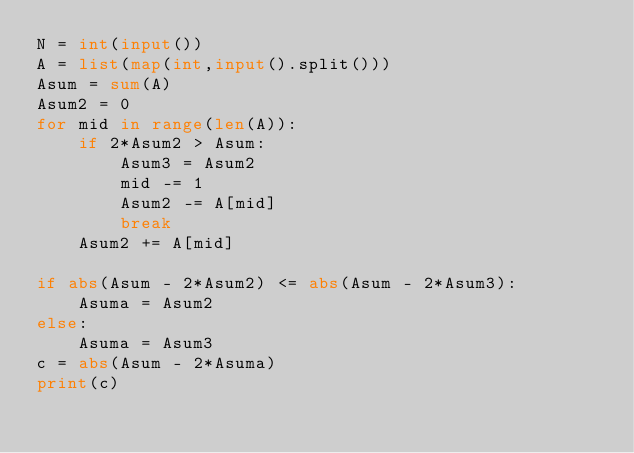<code> <loc_0><loc_0><loc_500><loc_500><_Python_>N = int(input())
A = list(map(int,input().split()))
Asum = sum(A)
Asum2 = 0
for mid in range(len(A)):
    if 2*Asum2 > Asum:
        Asum3 = Asum2
        mid -= 1
        Asum2 -= A[mid]
        break
    Asum2 += A[mid]

if abs(Asum - 2*Asum2) <= abs(Asum - 2*Asum3):
    Asuma = Asum2
else:
    Asuma = Asum3
c = abs(Asum - 2*Asuma)
print(c)
        </code> 